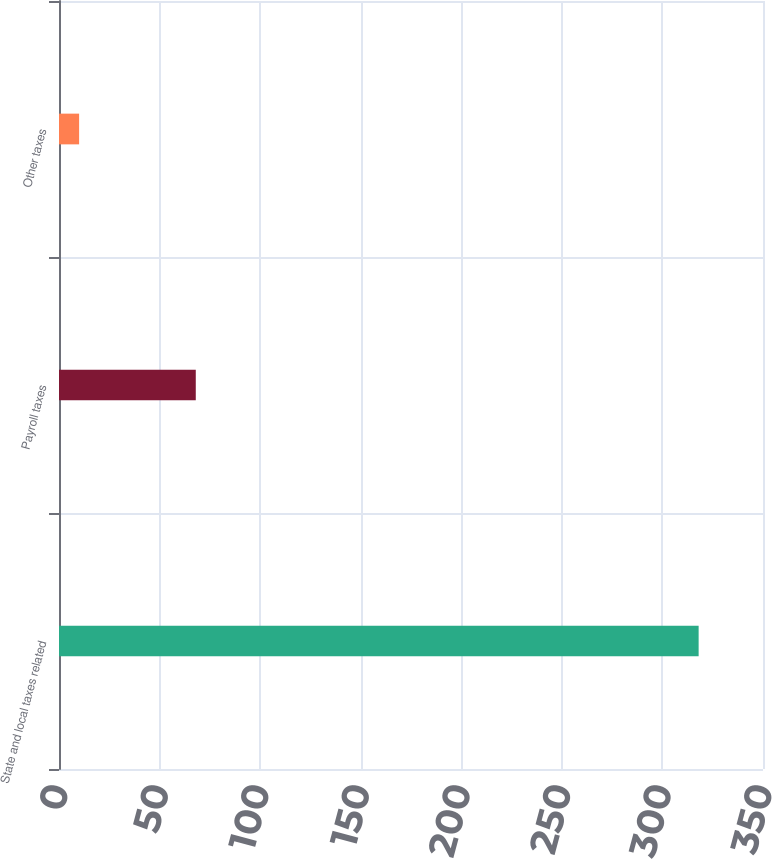<chart> <loc_0><loc_0><loc_500><loc_500><bar_chart><fcel>State and local taxes related<fcel>Payroll taxes<fcel>Other taxes<nl><fcel>318<fcel>68<fcel>10<nl></chart> 